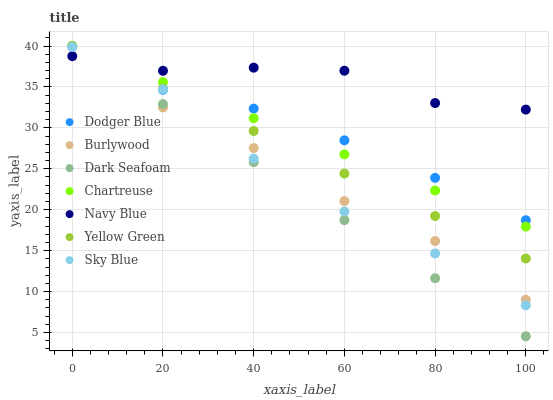Does Dark Seafoam have the minimum area under the curve?
Answer yes or no. Yes. Does Navy Blue have the maximum area under the curve?
Answer yes or no. Yes. Does Burlywood have the minimum area under the curve?
Answer yes or no. No. Does Burlywood have the maximum area under the curve?
Answer yes or no. No. Is Dark Seafoam the smoothest?
Answer yes or no. Yes. Is Navy Blue the roughest?
Answer yes or no. Yes. Is Burlywood the smoothest?
Answer yes or no. No. Is Burlywood the roughest?
Answer yes or no. No. Does Dark Seafoam have the lowest value?
Answer yes or no. Yes. Does Burlywood have the lowest value?
Answer yes or no. No. Does Dodger Blue have the highest value?
Answer yes or no. Yes. Does Navy Blue have the highest value?
Answer yes or no. No. Is Sky Blue less than Yellow Green?
Answer yes or no. Yes. Is Yellow Green greater than Sky Blue?
Answer yes or no. Yes. Does Navy Blue intersect Dark Seafoam?
Answer yes or no. Yes. Is Navy Blue less than Dark Seafoam?
Answer yes or no. No. Is Navy Blue greater than Dark Seafoam?
Answer yes or no. No. Does Sky Blue intersect Yellow Green?
Answer yes or no. No. 